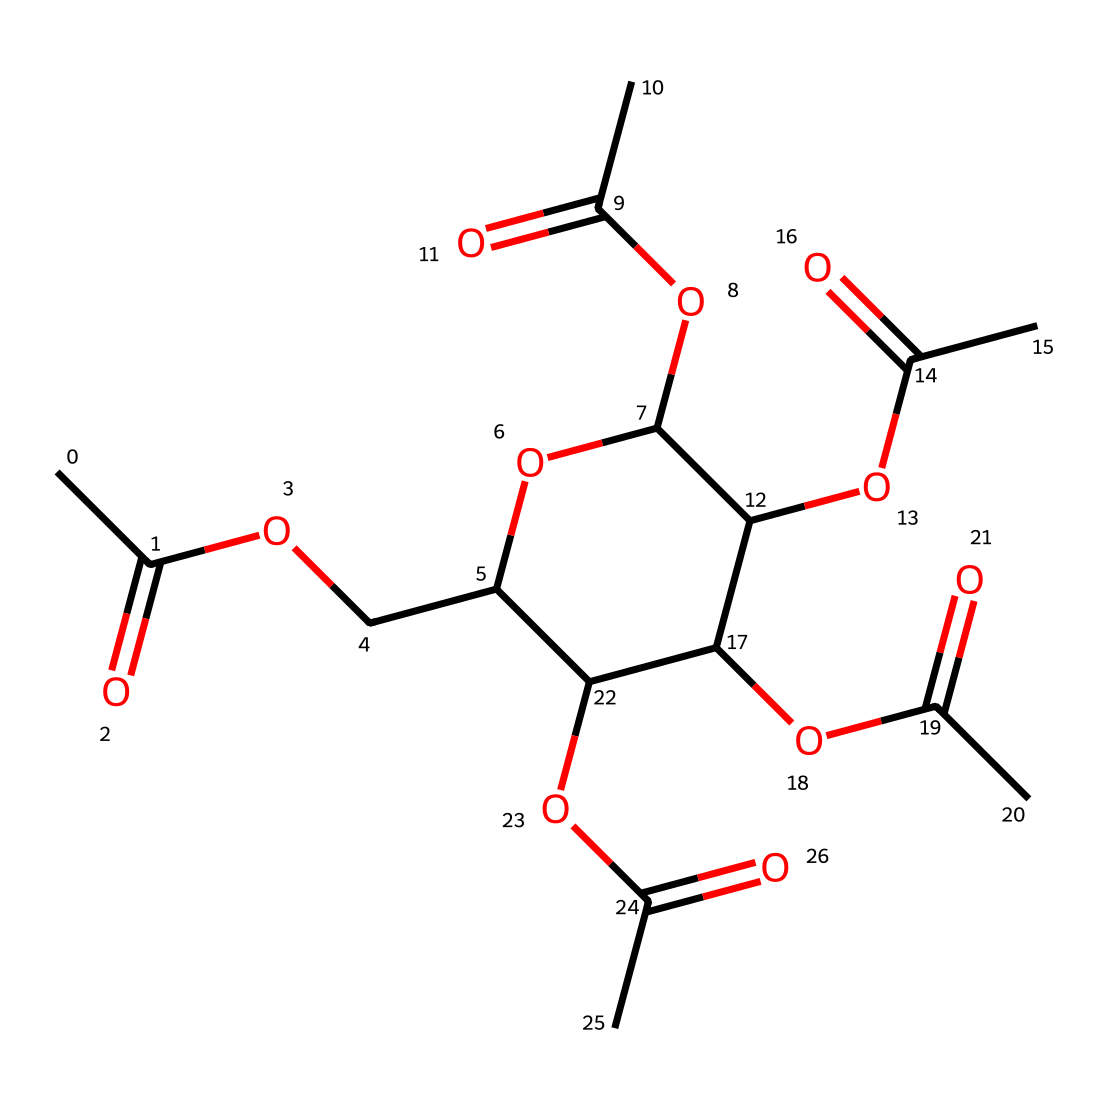What is the main functional group present in cellulose acetate? The main functional group in cellulose acetate is the acetate group, which is characterized by the presence of carbonyl and hydroxyl groups attached to an acetyl. Looking at the SMILES representation, the "CC(=O)" part indicates the presence of an acetyl group, signifying the acetate functionality.
Answer: acetate How many carbon atoms are in the structure of cellulose acetate? By analyzing the SMILES notation, each "C" denotes a carbon atom. Counting the carbon atoms present in the entire structure reveals there are 12 carbon atoms.
Answer: 12 What type of polymer is cellulose acetate? Cellulose acetate is a derivative of cellulose and classified as an acetate polymer. The structure indicates that it retains a cellulose backbone modified by acetate groups, making it specifically an acetate polymer.
Answer: acetate polymer What characteristic of the chemical structure makes cellulose acetate suitable for film reels? The presence of ester linkages in the acetate groups contributes to cellulose acetate's hydrophobic nature and flexibility, which are necessary for durability and stability in film reels. The structure shows multiple ester groups on the cellulose backbone, signifying its suitability for this application.
Answer: durability and flexibility What is the total number of functional groups in cellulose acetate? In the SMILES representation, we can identify four acetate groups, each contributing one functional group, and the cyclic ether structure contributes a limited number of additional functional groups. Upon careful examination, there are five functional groups identified overall in this structure.
Answer: 5 